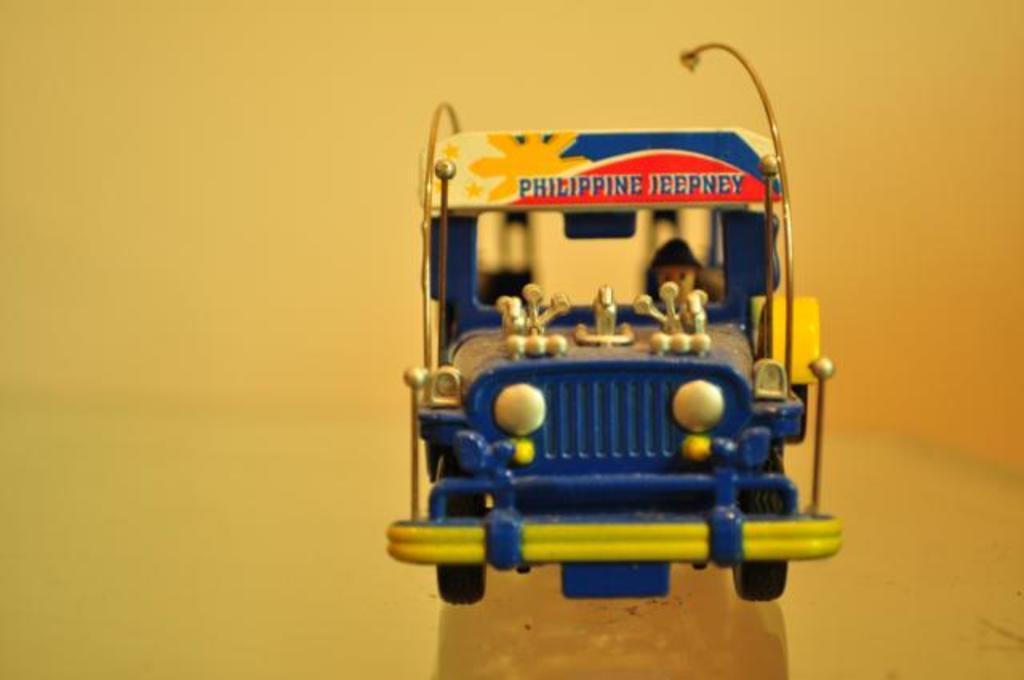In one or two sentences, can you explain what this image depicts? In this picture I can see a toy of a vehicle. The toy is blue in color. On the toy I can see something written on it. The background of the image is yellow in color. 